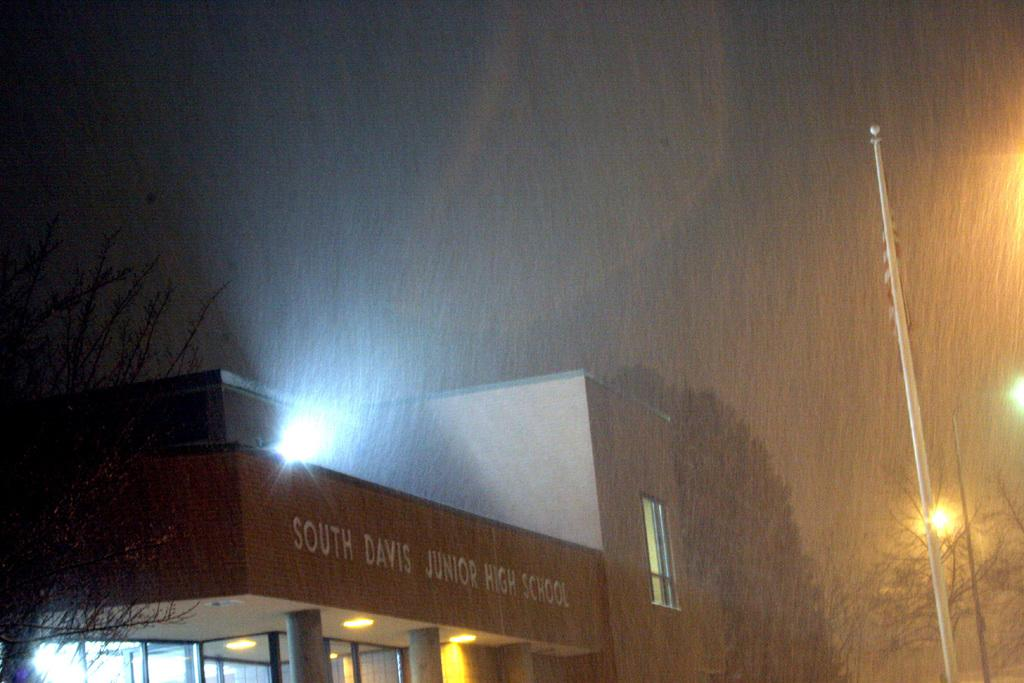What type of image is this? The image appears to be an edited photo. What is the main structure in the image? There is a building in the image. What can be seen illuminating the area in the image? There are lights in the image. What architectural features are present in the image? There are pillars in the image. What openings can be seen in the building? There are windows in the image. What type of vegetation is visible in the image? There are trees in the image. What structures are present to provide light along the path? There are light poles in the image. What is visible in the background of the image? The sky is visible in the image. How many cattle can be seen grazing in the image? There are no cattle present in the image. What is the person in the image doing to get the attention of the reader? There is no person present in the image, so it is not possible to determine what they might be doing to get the attention of the reader. 